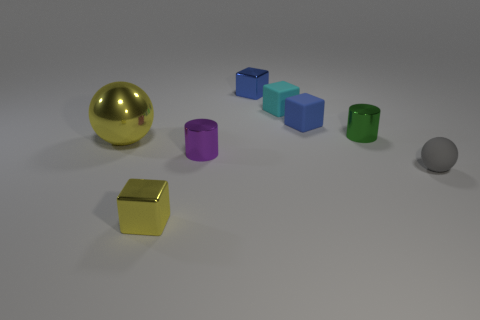What shape is the metallic thing behind the tiny green thing?
Your response must be concise. Cube. What is the color of the cylinder that is the same size as the green metallic object?
Offer a terse response. Purple. Is the small object that is to the left of the small purple cylinder made of the same material as the purple cylinder?
Your answer should be very brief. Yes. What is the size of the object that is in front of the large yellow ball and on the right side of the cyan matte block?
Provide a succinct answer. Small. There is a shiny cylinder that is in front of the big yellow shiny thing; how big is it?
Ensure brevity in your answer.  Small. There is a shiny object that is the same color as the shiny sphere; what shape is it?
Offer a terse response. Cube. There is a tiny blue thing in front of the blue thing that is left of the blue block that is in front of the cyan rubber thing; what shape is it?
Offer a very short reply. Cube. What number of other objects are the same shape as the big yellow thing?
Your response must be concise. 1. What number of shiny things are purple objects or large yellow objects?
Your answer should be very brief. 2. There is a yellow object that is behind the block that is in front of the green shiny cylinder; what is it made of?
Ensure brevity in your answer.  Metal. 